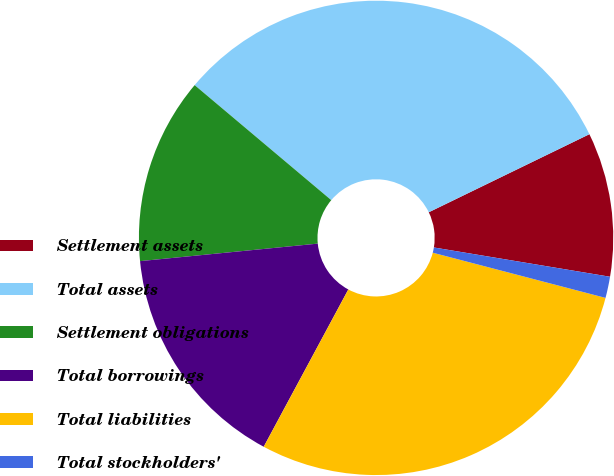<chart> <loc_0><loc_0><loc_500><loc_500><pie_chart><fcel>Settlement assets<fcel>Total assets<fcel>Settlement obligations<fcel>Total borrowings<fcel>Total liabilities<fcel>Total stockholders'<nl><fcel>9.82%<fcel>31.66%<fcel>12.7%<fcel>15.58%<fcel>28.78%<fcel>1.45%<nl></chart> 